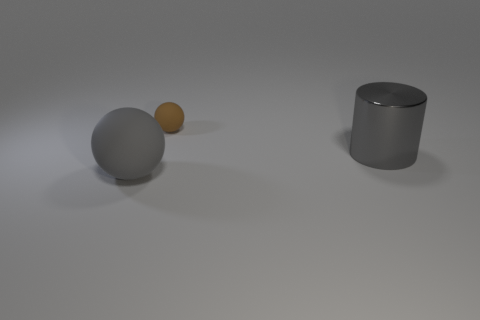Is there any other thing that is the same size as the brown ball?
Offer a very short reply. No. Is there anything else that has the same material as the gray cylinder?
Offer a terse response. No. Do the object behind the shiny thing and the gray matte thing have the same shape?
Your response must be concise. Yes. What number of objects are big purple matte things or objects to the left of the large metal thing?
Your answer should be compact. 2. Are there more big gray spheres that are in front of the large gray cylinder than big gray metallic blocks?
Provide a succinct answer. Yes. Are there the same number of objects left of the brown rubber thing and metallic objects that are on the left side of the gray rubber thing?
Your answer should be very brief. No. Are there any big gray rubber spheres that are in front of the ball that is behind the large gray cylinder?
Offer a very short reply. Yes. The large rubber object has what shape?
Give a very brief answer. Sphere. There is a rubber ball that is the same color as the big shiny cylinder; what size is it?
Give a very brief answer. Large. What size is the rubber sphere behind the large shiny object that is behind the big rubber sphere?
Make the answer very short. Small. 